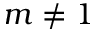<formula> <loc_0><loc_0><loc_500><loc_500>m \neq 1</formula> 